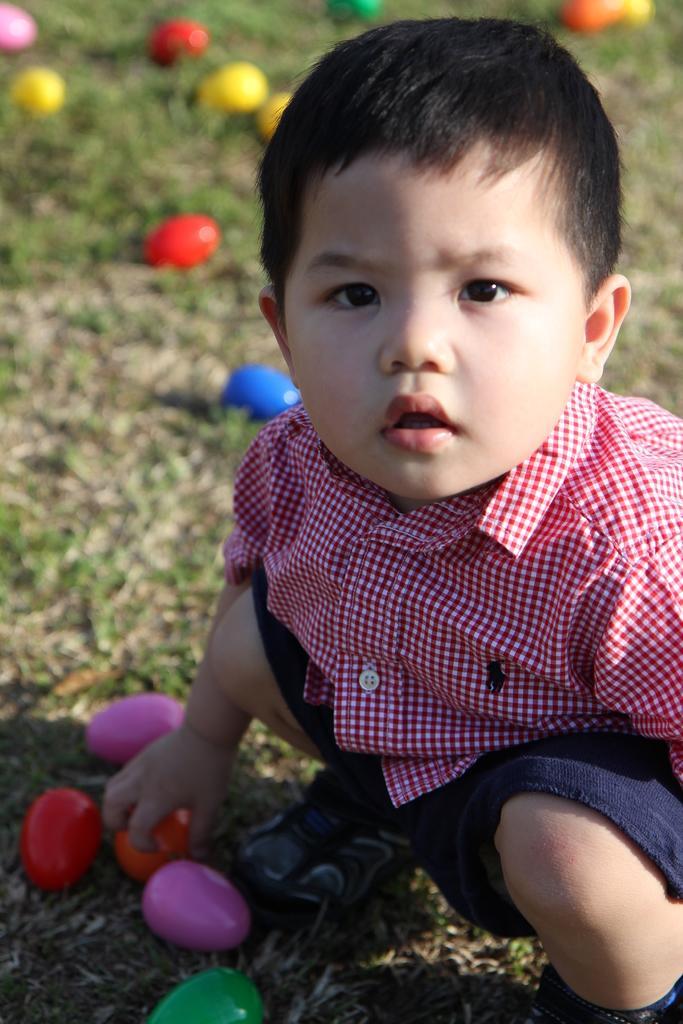In one or two sentences, can you explain what this image depicts? In this image I can see a boy wearing red shirt, blue short and shoe is sitting on the ground and holding a red colored object in his hand. In the background I can see some grass and few objects in the ground which are blue , red , yellow, pink, green and orange in color. 